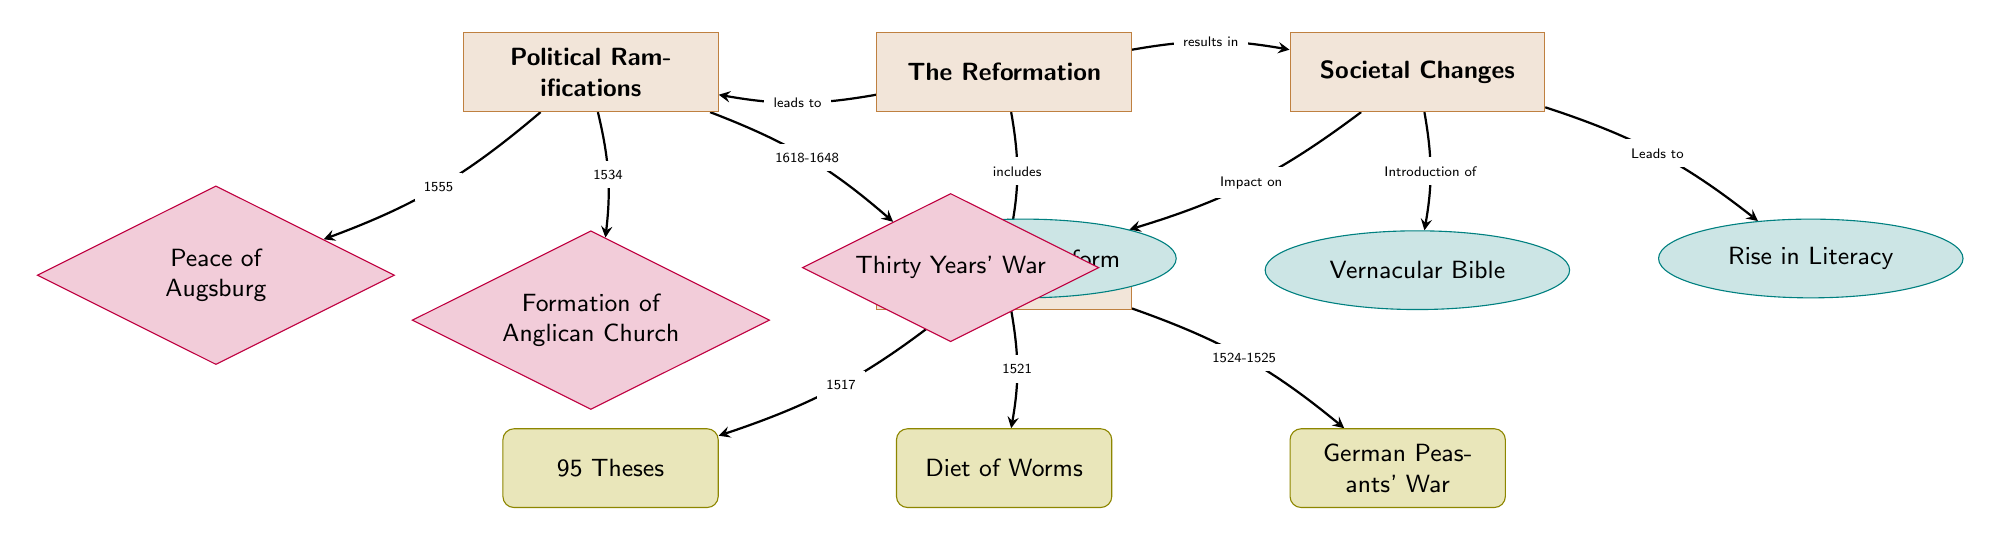What major event is associated with the year 1517? The diagram indicates that the "95 Theses" is linked to the year 1517 under the "Major Events" category. It is positioned directly below "Major Events" in the left section, indicating the specific timeline of when this event occurred.
Answer: 95 Theses Which societal change is directly related to the introduction of the vernacular Bible? The diagram shows a connection from the "Vernacular Bible" node to "Rise in Literacy" under the "Societal Changes" category. This implies that the introduction of the vernacular Bible is a precursor or cause for the increase in literacy levels during the Reformation period.
Answer: Rise in Literacy What significant political ramification occurred in 1555? In the "Political Ramifications" section, the "Peace of Augsburg" node is connected to the year 1555. This is a key event that indicates a political settlement achieved in that year as a result of the Reformation.
Answer: Peace of Augsburg How many major events are listed in the diagram? By counting the nodes under "Major Events," there are three events: "95 Theses," "Diet of Worms," and "German Peasants' War." This direct enumeration provides a clear answer regarding the number of major events depicted.
Answer: 3 What led to the formation of the Anglican Church? The diagram explicitly shows that the formation of the Anglican Church is situated beneath the "Political Ramifications" category and is connected to the year 1534. Therefore, the event that led to this formation is the year indicated in the diagram.
Answer: 1534 What societal change impacts education? The diagram connects the "Education Reform" node to the "Societal Changes" section. This suggests that education reform is noted as a direct impact from the Reformation, indicating its significance in the societal landscape.
Answer: Education Reform 